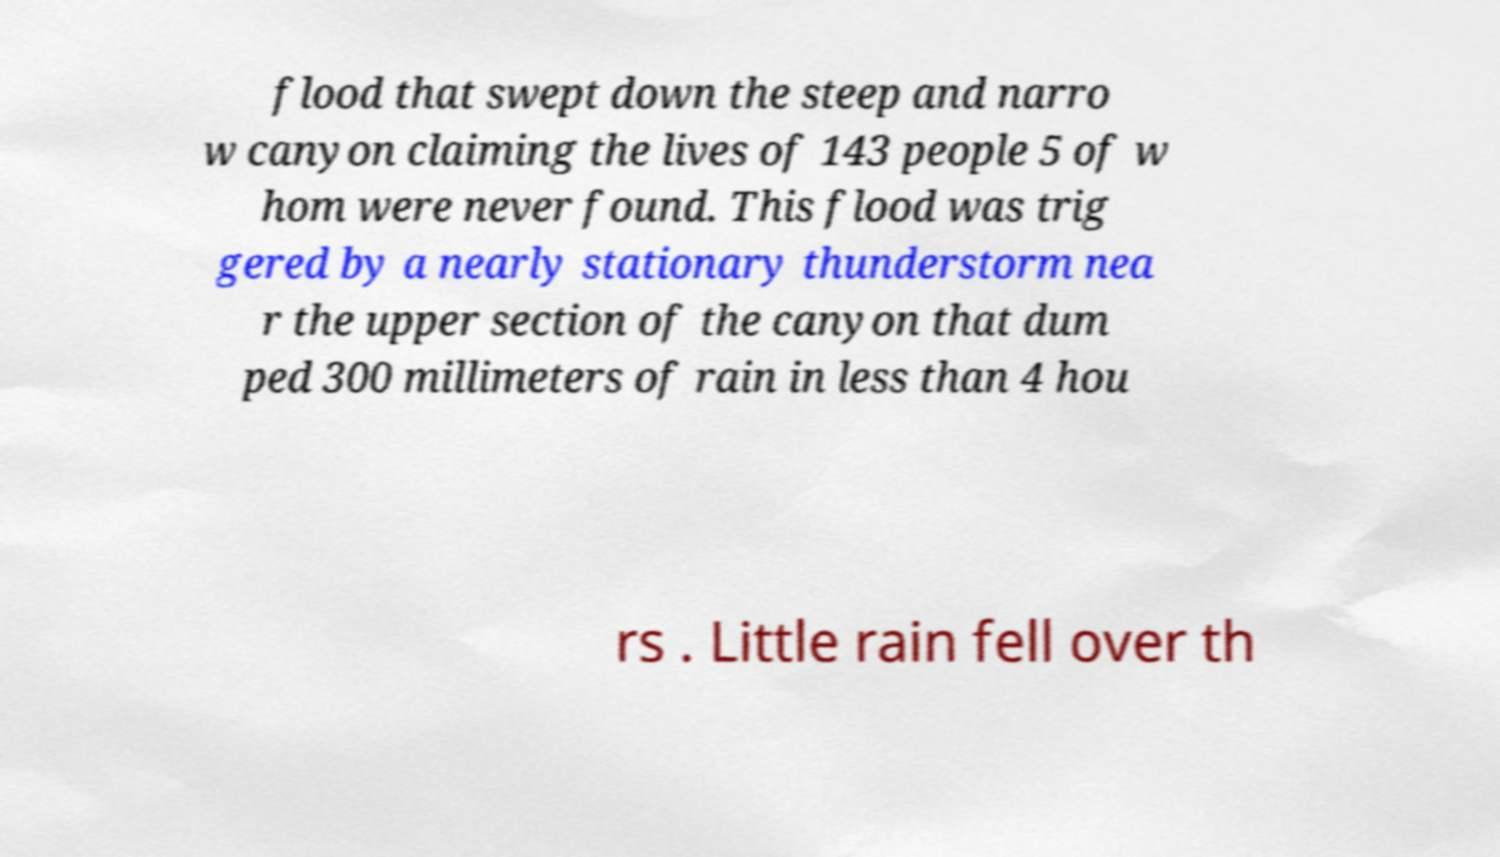Can you read and provide the text displayed in the image?This photo seems to have some interesting text. Can you extract and type it out for me? flood that swept down the steep and narro w canyon claiming the lives of 143 people 5 of w hom were never found. This flood was trig gered by a nearly stationary thunderstorm nea r the upper section of the canyon that dum ped 300 millimeters of rain in less than 4 hou rs . Little rain fell over th 